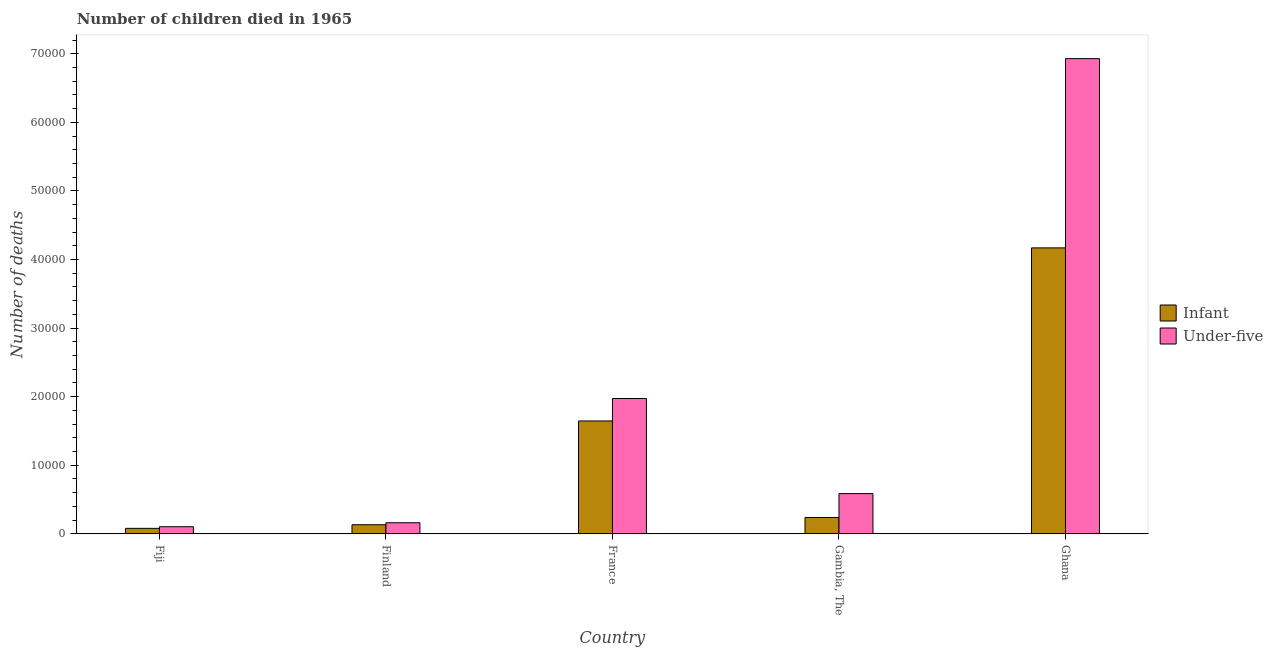Are the number of bars on each tick of the X-axis equal?
Offer a terse response. Yes. How many bars are there on the 1st tick from the left?
Your response must be concise. 2. How many bars are there on the 3rd tick from the right?
Make the answer very short. 2. What is the label of the 4th group of bars from the left?
Your response must be concise. Gambia, The. In how many cases, is the number of bars for a given country not equal to the number of legend labels?
Provide a short and direct response. 0. What is the number of under-five deaths in Ghana?
Provide a short and direct response. 6.93e+04. Across all countries, what is the maximum number of infant deaths?
Your answer should be compact. 4.17e+04. Across all countries, what is the minimum number of under-five deaths?
Your answer should be compact. 1041. In which country was the number of under-five deaths maximum?
Make the answer very short. Ghana. In which country was the number of under-five deaths minimum?
Ensure brevity in your answer.  Fiji. What is the total number of infant deaths in the graph?
Give a very brief answer. 6.27e+04. What is the difference between the number of infant deaths in Fiji and that in Gambia, The?
Give a very brief answer. -1583. What is the difference between the number of under-five deaths in Ghana and the number of infant deaths in Finland?
Give a very brief answer. 6.80e+04. What is the average number of infant deaths per country?
Give a very brief answer. 1.25e+04. What is the difference between the number of infant deaths and number of under-five deaths in Fiji?
Ensure brevity in your answer.  -237. What is the ratio of the number of under-five deaths in Finland to that in France?
Offer a terse response. 0.08. Is the number of infant deaths in Fiji less than that in Ghana?
Your response must be concise. Yes. What is the difference between the highest and the second highest number of under-five deaths?
Your answer should be compact. 4.96e+04. What is the difference between the highest and the lowest number of infant deaths?
Give a very brief answer. 4.09e+04. In how many countries, is the number of infant deaths greater than the average number of infant deaths taken over all countries?
Ensure brevity in your answer.  2. What does the 2nd bar from the left in France represents?
Your answer should be compact. Under-five. What does the 1st bar from the right in France represents?
Make the answer very short. Under-five. How many bars are there?
Provide a short and direct response. 10. Are all the bars in the graph horizontal?
Make the answer very short. No. How many countries are there in the graph?
Ensure brevity in your answer.  5. What is the difference between two consecutive major ticks on the Y-axis?
Offer a terse response. 10000. Are the values on the major ticks of Y-axis written in scientific E-notation?
Make the answer very short. No. Does the graph contain any zero values?
Offer a terse response. No. Does the graph contain grids?
Your answer should be very brief. No. Where does the legend appear in the graph?
Ensure brevity in your answer.  Center right. How are the legend labels stacked?
Give a very brief answer. Vertical. What is the title of the graph?
Give a very brief answer. Number of children died in 1965. Does "Quasi money growth" appear as one of the legend labels in the graph?
Keep it short and to the point. No. What is the label or title of the Y-axis?
Your answer should be very brief. Number of deaths. What is the Number of deaths of Infant in Fiji?
Offer a very short reply. 804. What is the Number of deaths of Under-five in Fiji?
Make the answer very short. 1041. What is the Number of deaths of Infant in Finland?
Provide a succinct answer. 1332. What is the Number of deaths of Under-five in Finland?
Offer a terse response. 1620. What is the Number of deaths in Infant in France?
Offer a terse response. 1.65e+04. What is the Number of deaths in Under-five in France?
Offer a very short reply. 1.97e+04. What is the Number of deaths of Infant in Gambia, The?
Keep it short and to the point. 2387. What is the Number of deaths in Under-five in Gambia, The?
Offer a terse response. 5872. What is the Number of deaths of Infant in Ghana?
Your response must be concise. 4.17e+04. What is the Number of deaths of Under-five in Ghana?
Keep it short and to the point. 6.93e+04. Across all countries, what is the maximum Number of deaths in Infant?
Provide a succinct answer. 4.17e+04. Across all countries, what is the maximum Number of deaths of Under-five?
Keep it short and to the point. 6.93e+04. Across all countries, what is the minimum Number of deaths in Infant?
Make the answer very short. 804. Across all countries, what is the minimum Number of deaths of Under-five?
Your answer should be very brief. 1041. What is the total Number of deaths of Infant in the graph?
Your answer should be compact. 6.27e+04. What is the total Number of deaths of Under-five in the graph?
Give a very brief answer. 9.76e+04. What is the difference between the Number of deaths in Infant in Fiji and that in Finland?
Make the answer very short. -528. What is the difference between the Number of deaths in Under-five in Fiji and that in Finland?
Your answer should be very brief. -579. What is the difference between the Number of deaths in Infant in Fiji and that in France?
Your response must be concise. -1.57e+04. What is the difference between the Number of deaths in Under-five in Fiji and that in France?
Your answer should be very brief. -1.87e+04. What is the difference between the Number of deaths of Infant in Fiji and that in Gambia, The?
Provide a succinct answer. -1583. What is the difference between the Number of deaths of Under-five in Fiji and that in Gambia, The?
Offer a very short reply. -4831. What is the difference between the Number of deaths in Infant in Fiji and that in Ghana?
Your answer should be very brief. -4.09e+04. What is the difference between the Number of deaths of Under-five in Fiji and that in Ghana?
Ensure brevity in your answer.  -6.83e+04. What is the difference between the Number of deaths in Infant in Finland and that in France?
Your response must be concise. -1.51e+04. What is the difference between the Number of deaths of Under-five in Finland and that in France?
Provide a short and direct response. -1.81e+04. What is the difference between the Number of deaths in Infant in Finland and that in Gambia, The?
Ensure brevity in your answer.  -1055. What is the difference between the Number of deaths of Under-five in Finland and that in Gambia, The?
Your response must be concise. -4252. What is the difference between the Number of deaths in Infant in Finland and that in Ghana?
Provide a short and direct response. -4.04e+04. What is the difference between the Number of deaths of Under-five in Finland and that in Ghana?
Your answer should be very brief. -6.77e+04. What is the difference between the Number of deaths of Infant in France and that in Gambia, The?
Offer a terse response. 1.41e+04. What is the difference between the Number of deaths of Under-five in France and that in Gambia, The?
Keep it short and to the point. 1.39e+04. What is the difference between the Number of deaths of Infant in France and that in Ghana?
Keep it short and to the point. -2.52e+04. What is the difference between the Number of deaths of Under-five in France and that in Ghana?
Keep it short and to the point. -4.96e+04. What is the difference between the Number of deaths of Infant in Gambia, The and that in Ghana?
Your answer should be very brief. -3.93e+04. What is the difference between the Number of deaths of Under-five in Gambia, The and that in Ghana?
Your answer should be compact. -6.34e+04. What is the difference between the Number of deaths in Infant in Fiji and the Number of deaths in Under-five in Finland?
Provide a succinct answer. -816. What is the difference between the Number of deaths of Infant in Fiji and the Number of deaths of Under-five in France?
Provide a succinct answer. -1.89e+04. What is the difference between the Number of deaths in Infant in Fiji and the Number of deaths in Under-five in Gambia, The?
Your response must be concise. -5068. What is the difference between the Number of deaths in Infant in Fiji and the Number of deaths in Under-five in Ghana?
Ensure brevity in your answer.  -6.85e+04. What is the difference between the Number of deaths in Infant in Finland and the Number of deaths in Under-five in France?
Provide a short and direct response. -1.84e+04. What is the difference between the Number of deaths of Infant in Finland and the Number of deaths of Under-five in Gambia, The?
Provide a succinct answer. -4540. What is the difference between the Number of deaths of Infant in Finland and the Number of deaths of Under-five in Ghana?
Provide a succinct answer. -6.80e+04. What is the difference between the Number of deaths of Infant in France and the Number of deaths of Under-five in Gambia, The?
Keep it short and to the point. 1.06e+04. What is the difference between the Number of deaths in Infant in France and the Number of deaths in Under-five in Ghana?
Keep it short and to the point. -5.28e+04. What is the difference between the Number of deaths in Infant in Gambia, The and the Number of deaths in Under-five in Ghana?
Provide a short and direct response. -6.69e+04. What is the average Number of deaths in Infant per country?
Provide a short and direct response. 1.25e+04. What is the average Number of deaths in Under-five per country?
Ensure brevity in your answer.  1.95e+04. What is the difference between the Number of deaths in Infant and Number of deaths in Under-five in Fiji?
Provide a succinct answer. -237. What is the difference between the Number of deaths in Infant and Number of deaths in Under-five in Finland?
Your answer should be compact. -288. What is the difference between the Number of deaths in Infant and Number of deaths in Under-five in France?
Offer a very short reply. -3273. What is the difference between the Number of deaths of Infant and Number of deaths of Under-five in Gambia, The?
Your answer should be compact. -3485. What is the difference between the Number of deaths of Infant and Number of deaths of Under-five in Ghana?
Keep it short and to the point. -2.76e+04. What is the ratio of the Number of deaths of Infant in Fiji to that in Finland?
Make the answer very short. 0.6. What is the ratio of the Number of deaths in Under-five in Fiji to that in Finland?
Your response must be concise. 0.64. What is the ratio of the Number of deaths of Infant in Fiji to that in France?
Give a very brief answer. 0.05. What is the ratio of the Number of deaths of Under-five in Fiji to that in France?
Offer a very short reply. 0.05. What is the ratio of the Number of deaths in Infant in Fiji to that in Gambia, The?
Provide a succinct answer. 0.34. What is the ratio of the Number of deaths in Under-five in Fiji to that in Gambia, The?
Offer a terse response. 0.18. What is the ratio of the Number of deaths in Infant in Fiji to that in Ghana?
Make the answer very short. 0.02. What is the ratio of the Number of deaths of Under-five in Fiji to that in Ghana?
Ensure brevity in your answer.  0.01. What is the ratio of the Number of deaths of Infant in Finland to that in France?
Give a very brief answer. 0.08. What is the ratio of the Number of deaths of Under-five in Finland to that in France?
Keep it short and to the point. 0.08. What is the ratio of the Number of deaths in Infant in Finland to that in Gambia, The?
Keep it short and to the point. 0.56. What is the ratio of the Number of deaths in Under-five in Finland to that in Gambia, The?
Offer a terse response. 0.28. What is the ratio of the Number of deaths of Infant in Finland to that in Ghana?
Give a very brief answer. 0.03. What is the ratio of the Number of deaths of Under-five in Finland to that in Ghana?
Provide a short and direct response. 0.02. What is the ratio of the Number of deaths of Infant in France to that in Gambia, The?
Provide a short and direct response. 6.9. What is the ratio of the Number of deaths of Under-five in France to that in Gambia, The?
Your answer should be very brief. 3.36. What is the ratio of the Number of deaths in Infant in France to that in Ghana?
Your response must be concise. 0.39. What is the ratio of the Number of deaths of Under-five in France to that in Ghana?
Ensure brevity in your answer.  0.28. What is the ratio of the Number of deaths of Infant in Gambia, The to that in Ghana?
Provide a short and direct response. 0.06. What is the ratio of the Number of deaths of Under-five in Gambia, The to that in Ghana?
Your response must be concise. 0.08. What is the difference between the highest and the second highest Number of deaths of Infant?
Ensure brevity in your answer.  2.52e+04. What is the difference between the highest and the second highest Number of deaths in Under-five?
Make the answer very short. 4.96e+04. What is the difference between the highest and the lowest Number of deaths of Infant?
Your answer should be compact. 4.09e+04. What is the difference between the highest and the lowest Number of deaths in Under-five?
Ensure brevity in your answer.  6.83e+04. 